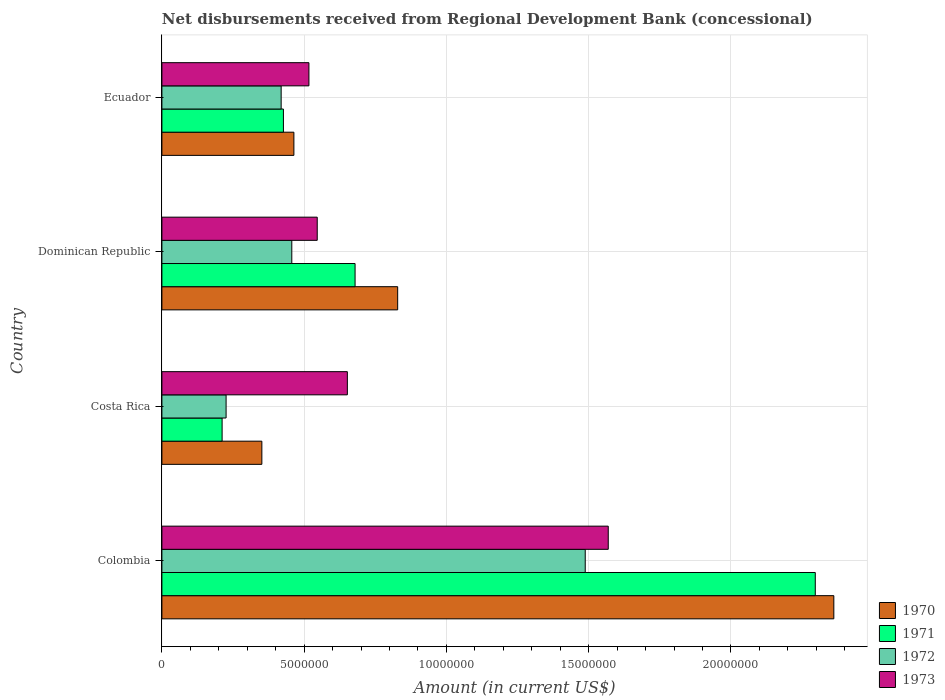How many groups of bars are there?
Ensure brevity in your answer.  4. Are the number of bars on each tick of the Y-axis equal?
Provide a succinct answer. Yes. How many bars are there on the 2nd tick from the bottom?
Give a very brief answer. 4. What is the label of the 2nd group of bars from the top?
Your answer should be very brief. Dominican Republic. In how many cases, is the number of bars for a given country not equal to the number of legend labels?
Make the answer very short. 0. What is the amount of disbursements received from Regional Development Bank in 1970 in Colombia?
Your answer should be compact. 2.36e+07. Across all countries, what is the maximum amount of disbursements received from Regional Development Bank in 1973?
Offer a terse response. 1.57e+07. Across all countries, what is the minimum amount of disbursements received from Regional Development Bank in 1972?
Your answer should be compact. 2.26e+06. In which country was the amount of disbursements received from Regional Development Bank in 1970 maximum?
Make the answer very short. Colombia. In which country was the amount of disbursements received from Regional Development Bank in 1973 minimum?
Provide a succinct answer. Ecuador. What is the total amount of disbursements received from Regional Development Bank in 1972 in the graph?
Provide a short and direct response. 2.59e+07. What is the difference between the amount of disbursements received from Regional Development Bank in 1972 in Colombia and that in Ecuador?
Your answer should be very brief. 1.07e+07. What is the difference between the amount of disbursements received from Regional Development Bank in 1972 in Dominican Republic and the amount of disbursements received from Regional Development Bank in 1970 in Costa Rica?
Your answer should be compact. 1.05e+06. What is the average amount of disbursements received from Regional Development Bank in 1971 per country?
Give a very brief answer. 9.03e+06. In how many countries, is the amount of disbursements received from Regional Development Bank in 1970 greater than 1000000 US$?
Make the answer very short. 4. What is the ratio of the amount of disbursements received from Regional Development Bank in 1972 in Costa Rica to that in Ecuador?
Make the answer very short. 0.54. What is the difference between the highest and the second highest amount of disbursements received from Regional Development Bank in 1973?
Make the answer very short. 9.17e+06. What is the difference between the highest and the lowest amount of disbursements received from Regional Development Bank in 1971?
Provide a succinct answer. 2.08e+07. In how many countries, is the amount of disbursements received from Regional Development Bank in 1970 greater than the average amount of disbursements received from Regional Development Bank in 1970 taken over all countries?
Provide a succinct answer. 1. Is the sum of the amount of disbursements received from Regional Development Bank in 1972 in Costa Rica and Dominican Republic greater than the maximum amount of disbursements received from Regional Development Bank in 1970 across all countries?
Your response must be concise. No. What does the 4th bar from the top in Colombia represents?
Ensure brevity in your answer.  1970. What does the 3rd bar from the bottom in Ecuador represents?
Keep it short and to the point. 1972. Is it the case that in every country, the sum of the amount of disbursements received from Regional Development Bank in 1970 and amount of disbursements received from Regional Development Bank in 1973 is greater than the amount of disbursements received from Regional Development Bank in 1972?
Provide a short and direct response. Yes. How many bars are there?
Give a very brief answer. 16. How many countries are there in the graph?
Your answer should be compact. 4. Are the values on the major ticks of X-axis written in scientific E-notation?
Your answer should be very brief. No. How are the legend labels stacked?
Provide a short and direct response. Vertical. What is the title of the graph?
Give a very brief answer. Net disbursements received from Regional Development Bank (concessional). What is the label or title of the Y-axis?
Your response must be concise. Country. What is the Amount (in current US$) in 1970 in Colombia?
Ensure brevity in your answer.  2.36e+07. What is the Amount (in current US$) in 1971 in Colombia?
Provide a short and direct response. 2.30e+07. What is the Amount (in current US$) of 1972 in Colombia?
Your answer should be very brief. 1.49e+07. What is the Amount (in current US$) in 1973 in Colombia?
Ensure brevity in your answer.  1.57e+07. What is the Amount (in current US$) of 1970 in Costa Rica?
Make the answer very short. 3.51e+06. What is the Amount (in current US$) of 1971 in Costa Rica?
Give a very brief answer. 2.12e+06. What is the Amount (in current US$) in 1972 in Costa Rica?
Your answer should be compact. 2.26e+06. What is the Amount (in current US$) in 1973 in Costa Rica?
Your answer should be compact. 6.52e+06. What is the Amount (in current US$) in 1970 in Dominican Republic?
Ensure brevity in your answer.  8.29e+06. What is the Amount (in current US$) in 1971 in Dominican Republic?
Make the answer very short. 6.79e+06. What is the Amount (in current US$) of 1972 in Dominican Republic?
Ensure brevity in your answer.  4.56e+06. What is the Amount (in current US$) in 1973 in Dominican Republic?
Provide a short and direct response. 5.46e+06. What is the Amount (in current US$) of 1970 in Ecuador?
Make the answer very short. 4.64e+06. What is the Amount (in current US$) of 1971 in Ecuador?
Your answer should be very brief. 4.27e+06. What is the Amount (in current US$) of 1972 in Ecuador?
Give a very brief answer. 4.19e+06. What is the Amount (in current US$) of 1973 in Ecuador?
Keep it short and to the point. 5.17e+06. Across all countries, what is the maximum Amount (in current US$) of 1970?
Keep it short and to the point. 2.36e+07. Across all countries, what is the maximum Amount (in current US$) in 1971?
Keep it short and to the point. 2.30e+07. Across all countries, what is the maximum Amount (in current US$) in 1972?
Ensure brevity in your answer.  1.49e+07. Across all countries, what is the maximum Amount (in current US$) of 1973?
Make the answer very short. 1.57e+07. Across all countries, what is the minimum Amount (in current US$) of 1970?
Keep it short and to the point. 3.51e+06. Across all countries, what is the minimum Amount (in current US$) of 1971?
Provide a succinct answer. 2.12e+06. Across all countries, what is the minimum Amount (in current US$) in 1972?
Provide a succinct answer. 2.26e+06. Across all countries, what is the minimum Amount (in current US$) in 1973?
Your answer should be very brief. 5.17e+06. What is the total Amount (in current US$) in 1970 in the graph?
Keep it short and to the point. 4.01e+07. What is the total Amount (in current US$) in 1971 in the graph?
Your answer should be very brief. 3.61e+07. What is the total Amount (in current US$) in 1972 in the graph?
Give a very brief answer. 2.59e+07. What is the total Amount (in current US$) in 1973 in the graph?
Give a very brief answer. 3.28e+07. What is the difference between the Amount (in current US$) in 1970 in Colombia and that in Costa Rica?
Offer a very short reply. 2.01e+07. What is the difference between the Amount (in current US$) of 1971 in Colombia and that in Costa Rica?
Keep it short and to the point. 2.08e+07. What is the difference between the Amount (in current US$) in 1972 in Colombia and that in Costa Rica?
Make the answer very short. 1.26e+07. What is the difference between the Amount (in current US$) in 1973 in Colombia and that in Costa Rica?
Give a very brief answer. 9.17e+06. What is the difference between the Amount (in current US$) in 1970 in Colombia and that in Dominican Republic?
Your answer should be compact. 1.53e+07. What is the difference between the Amount (in current US$) of 1971 in Colombia and that in Dominican Republic?
Offer a very short reply. 1.62e+07. What is the difference between the Amount (in current US$) in 1972 in Colombia and that in Dominican Republic?
Make the answer very short. 1.03e+07. What is the difference between the Amount (in current US$) in 1973 in Colombia and that in Dominican Republic?
Your answer should be very brief. 1.02e+07. What is the difference between the Amount (in current US$) in 1970 in Colombia and that in Ecuador?
Your answer should be compact. 1.90e+07. What is the difference between the Amount (in current US$) in 1971 in Colombia and that in Ecuador?
Ensure brevity in your answer.  1.87e+07. What is the difference between the Amount (in current US$) of 1972 in Colombia and that in Ecuador?
Offer a terse response. 1.07e+07. What is the difference between the Amount (in current US$) of 1973 in Colombia and that in Ecuador?
Provide a short and direct response. 1.05e+07. What is the difference between the Amount (in current US$) in 1970 in Costa Rica and that in Dominican Republic?
Your answer should be compact. -4.77e+06. What is the difference between the Amount (in current US$) of 1971 in Costa Rica and that in Dominican Republic?
Your response must be concise. -4.67e+06. What is the difference between the Amount (in current US$) of 1972 in Costa Rica and that in Dominican Republic?
Provide a short and direct response. -2.31e+06. What is the difference between the Amount (in current US$) of 1973 in Costa Rica and that in Dominican Republic?
Offer a very short reply. 1.06e+06. What is the difference between the Amount (in current US$) in 1970 in Costa Rica and that in Ecuador?
Your answer should be very brief. -1.13e+06. What is the difference between the Amount (in current US$) in 1971 in Costa Rica and that in Ecuador?
Offer a very short reply. -2.16e+06. What is the difference between the Amount (in current US$) of 1972 in Costa Rica and that in Ecuador?
Your response must be concise. -1.94e+06. What is the difference between the Amount (in current US$) in 1973 in Costa Rica and that in Ecuador?
Keep it short and to the point. 1.35e+06. What is the difference between the Amount (in current US$) of 1970 in Dominican Republic and that in Ecuador?
Give a very brief answer. 3.65e+06. What is the difference between the Amount (in current US$) of 1971 in Dominican Republic and that in Ecuador?
Provide a short and direct response. 2.52e+06. What is the difference between the Amount (in current US$) in 1972 in Dominican Republic and that in Ecuador?
Your answer should be very brief. 3.74e+05. What is the difference between the Amount (in current US$) of 1973 in Dominican Republic and that in Ecuador?
Ensure brevity in your answer.  2.92e+05. What is the difference between the Amount (in current US$) in 1970 in Colombia and the Amount (in current US$) in 1971 in Costa Rica?
Your answer should be compact. 2.15e+07. What is the difference between the Amount (in current US$) in 1970 in Colombia and the Amount (in current US$) in 1972 in Costa Rica?
Offer a terse response. 2.14e+07. What is the difference between the Amount (in current US$) in 1970 in Colombia and the Amount (in current US$) in 1973 in Costa Rica?
Provide a short and direct response. 1.71e+07. What is the difference between the Amount (in current US$) in 1971 in Colombia and the Amount (in current US$) in 1972 in Costa Rica?
Offer a very short reply. 2.07e+07. What is the difference between the Amount (in current US$) in 1971 in Colombia and the Amount (in current US$) in 1973 in Costa Rica?
Provide a succinct answer. 1.64e+07. What is the difference between the Amount (in current US$) in 1972 in Colombia and the Amount (in current US$) in 1973 in Costa Rica?
Your answer should be very brief. 8.36e+06. What is the difference between the Amount (in current US$) of 1970 in Colombia and the Amount (in current US$) of 1971 in Dominican Republic?
Give a very brief answer. 1.68e+07. What is the difference between the Amount (in current US$) in 1970 in Colombia and the Amount (in current US$) in 1972 in Dominican Republic?
Provide a short and direct response. 1.90e+07. What is the difference between the Amount (in current US$) of 1970 in Colombia and the Amount (in current US$) of 1973 in Dominican Republic?
Make the answer very short. 1.82e+07. What is the difference between the Amount (in current US$) of 1971 in Colombia and the Amount (in current US$) of 1972 in Dominican Republic?
Provide a succinct answer. 1.84e+07. What is the difference between the Amount (in current US$) of 1971 in Colombia and the Amount (in current US$) of 1973 in Dominican Republic?
Offer a terse response. 1.75e+07. What is the difference between the Amount (in current US$) of 1972 in Colombia and the Amount (in current US$) of 1973 in Dominican Republic?
Offer a very short reply. 9.42e+06. What is the difference between the Amount (in current US$) of 1970 in Colombia and the Amount (in current US$) of 1971 in Ecuador?
Give a very brief answer. 1.93e+07. What is the difference between the Amount (in current US$) in 1970 in Colombia and the Amount (in current US$) in 1972 in Ecuador?
Your answer should be very brief. 1.94e+07. What is the difference between the Amount (in current US$) in 1970 in Colombia and the Amount (in current US$) in 1973 in Ecuador?
Your response must be concise. 1.84e+07. What is the difference between the Amount (in current US$) of 1971 in Colombia and the Amount (in current US$) of 1972 in Ecuador?
Keep it short and to the point. 1.88e+07. What is the difference between the Amount (in current US$) in 1971 in Colombia and the Amount (in current US$) in 1973 in Ecuador?
Offer a terse response. 1.78e+07. What is the difference between the Amount (in current US$) in 1972 in Colombia and the Amount (in current US$) in 1973 in Ecuador?
Your answer should be compact. 9.71e+06. What is the difference between the Amount (in current US$) in 1970 in Costa Rica and the Amount (in current US$) in 1971 in Dominican Republic?
Provide a short and direct response. -3.28e+06. What is the difference between the Amount (in current US$) of 1970 in Costa Rica and the Amount (in current US$) of 1972 in Dominican Republic?
Your response must be concise. -1.05e+06. What is the difference between the Amount (in current US$) in 1970 in Costa Rica and the Amount (in current US$) in 1973 in Dominican Republic?
Provide a short and direct response. -1.95e+06. What is the difference between the Amount (in current US$) of 1971 in Costa Rica and the Amount (in current US$) of 1972 in Dominican Republic?
Ensure brevity in your answer.  -2.45e+06. What is the difference between the Amount (in current US$) in 1971 in Costa Rica and the Amount (in current US$) in 1973 in Dominican Republic?
Provide a short and direct response. -3.34e+06. What is the difference between the Amount (in current US$) in 1972 in Costa Rica and the Amount (in current US$) in 1973 in Dominican Republic?
Offer a very short reply. -3.20e+06. What is the difference between the Amount (in current US$) of 1970 in Costa Rica and the Amount (in current US$) of 1971 in Ecuador?
Give a very brief answer. -7.58e+05. What is the difference between the Amount (in current US$) of 1970 in Costa Rica and the Amount (in current US$) of 1972 in Ecuador?
Your answer should be very brief. -6.78e+05. What is the difference between the Amount (in current US$) of 1970 in Costa Rica and the Amount (in current US$) of 1973 in Ecuador?
Provide a succinct answer. -1.65e+06. What is the difference between the Amount (in current US$) in 1971 in Costa Rica and the Amount (in current US$) in 1972 in Ecuador?
Provide a short and direct response. -2.08e+06. What is the difference between the Amount (in current US$) in 1971 in Costa Rica and the Amount (in current US$) in 1973 in Ecuador?
Keep it short and to the point. -3.05e+06. What is the difference between the Amount (in current US$) in 1972 in Costa Rica and the Amount (in current US$) in 1973 in Ecuador?
Your answer should be compact. -2.91e+06. What is the difference between the Amount (in current US$) of 1970 in Dominican Republic and the Amount (in current US$) of 1971 in Ecuador?
Keep it short and to the point. 4.02e+06. What is the difference between the Amount (in current US$) in 1970 in Dominican Republic and the Amount (in current US$) in 1972 in Ecuador?
Provide a succinct answer. 4.10e+06. What is the difference between the Amount (in current US$) of 1970 in Dominican Republic and the Amount (in current US$) of 1973 in Ecuador?
Offer a very short reply. 3.12e+06. What is the difference between the Amount (in current US$) in 1971 in Dominican Republic and the Amount (in current US$) in 1972 in Ecuador?
Offer a very short reply. 2.60e+06. What is the difference between the Amount (in current US$) in 1971 in Dominican Republic and the Amount (in current US$) in 1973 in Ecuador?
Provide a short and direct response. 1.62e+06. What is the difference between the Amount (in current US$) of 1972 in Dominican Republic and the Amount (in current US$) of 1973 in Ecuador?
Give a very brief answer. -6.02e+05. What is the average Amount (in current US$) in 1970 per country?
Offer a terse response. 1.00e+07. What is the average Amount (in current US$) of 1971 per country?
Your answer should be very brief. 9.03e+06. What is the average Amount (in current US$) in 1972 per country?
Your answer should be compact. 6.47e+06. What is the average Amount (in current US$) of 1973 per country?
Ensure brevity in your answer.  8.21e+06. What is the difference between the Amount (in current US$) in 1970 and Amount (in current US$) in 1971 in Colombia?
Make the answer very short. 6.52e+05. What is the difference between the Amount (in current US$) of 1970 and Amount (in current US$) of 1972 in Colombia?
Provide a short and direct response. 8.74e+06. What is the difference between the Amount (in current US$) of 1970 and Amount (in current US$) of 1973 in Colombia?
Offer a very short reply. 7.93e+06. What is the difference between the Amount (in current US$) of 1971 and Amount (in current US$) of 1972 in Colombia?
Offer a terse response. 8.08e+06. What is the difference between the Amount (in current US$) of 1971 and Amount (in current US$) of 1973 in Colombia?
Your response must be concise. 7.28e+06. What is the difference between the Amount (in current US$) in 1972 and Amount (in current US$) in 1973 in Colombia?
Offer a very short reply. -8.09e+05. What is the difference between the Amount (in current US$) in 1970 and Amount (in current US$) in 1971 in Costa Rica?
Offer a very short reply. 1.40e+06. What is the difference between the Amount (in current US$) of 1970 and Amount (in current US$) of 1972 in Costa Rica?
Make the answer very short. 1.26e+06. What is the difference between the Amount (in current US$) of 1970 and Amount (in current US$) of 1973 in Costa Rica?
Your answer should be very brief. -3.00e+06. What is the difference between the Amount (in current US$) in 1971 and Amount (in current US$) in 1973 in Costa Rica?
Your answer should be very brief. -4.40e+06. What is the difference between the Amount (in current US$) in 1972 and Amount (in current US$) in 1973 in Costa Rica?
Give a very brief answer. -4.26e+06. What is the difference between the Amount (in current US$) in 1970 and Amount (in current US$) in 1971 in Dominican Republic?
Your answer should be compact. 1.50e+06. What is the difference between the Amount (in current US$) of 1970 and Amount (in current US$) of 1972 in Dominican Republic?
Your response must be concise. 3.72e+06. What is the difference between the Amount (in current US$) of 1970 and Amount (in current US$) of 1973 in Dominican Republic?
Provide a succinct answer. 2.83e+06. What is the difference between the Amount (in current US$) of 1971 and Amount (in current US$) of 1972 in Dominican Republic?
Offer a very short reply. 2.22e+06. What is the difference between the Amount (in current US$) in 1971 and Amount (in current US$) in 1973 in Dominican Republic?
Provide a short and direct response. 1.33e+06. What is the difference between the Amount (in current US$) of 1972 and Amount (in current US$) of 1973 in Dominican Republic?
Your answer should be compact. -8.94e+05. What is the difference between the Amount (in current US$) of 1970 and Amount (in current US$) of 1971 in Ecuador?
Your answer should be very brief. 3.68e+05. What is the difference between the Amount (in current US$) of 1970 and Amount (in current US$) of 1972 in Ecuador?
Your answer should be very brief. 4.48e+05. What is the difference between the Amount (in current US$) of 1970 and Amount (in current US$) of 1973 in Ecuador?
Your answer should be very brief. -5.28e+05. What is the difference between the Amount (in current US$) in 1971 and Amount (in current US$) in 1973 in Ecuador?
Make the answer very short. -8.96e+05. What is the difference between the Amount (in current US$) in 1972 and Amount (in current US$) in 1973 in Ecuador?
Provide a short and direct response. -9.76e+05. What is the ratio of the Amount (in current US$) of 1970 in Colombia to that in Costa Rica?
Make the answer very short. 6.72. What is the ratio of the Amount (in current US$) of 1971 in Colombia to that in Costa Rica?
Make the answer very short. 10.85. What is the ratio of the Amount (in current US$) in 1972 in Colombia to that in Costa Rica?
Ensure brevity in your answer.  6.59. What is the ratio of the Amount (in current US$) in 1973 in Colombia to that in Costa Rica?
Offer a terse response. 2.41. What is the ratio of the Amount (in current US$) of 1970 in Colombia to that in Dominican Republic?
Give a very brief answer. 2.85. What is the ratio of the Amount (in current US$) in 1971 in Colombia to that in Dominican Republic?
Your answer should be compact. 3.38. What is the ratio of the Amount (in current US$) of 1972 in Colombia to that in Dominican Republic?
Provide a short and direct response. 3.26. What is the ratio of the Amount (in current US$) of 1973 in Colombia to that in Dominican Republic?
Offer a very short reply. 2.87. What is the ratio of the Amount (in current US$) of 1970 in Colombia to that in Ecuador?
Make the answer very short. 5.09. What is the ratio of the Amount (in current US$) of 1971 in Colombia to that in Ecuador?
Provide a succinct answer. 5.38. What is the ratio of the Amount (in current US$) in 1972 in Colombia to that in Ecuador?
Ensure brevity in your answer.  3.55. What is the ratio of the Amount (in current US$) in 1973 in Colombia to that in Ecuador?
Ensure brevity in your answer.  3.04. What is the ratio of the Amount (in current US$) in 1970 in Costa Rica to that in Dominican Republic?
Give a very brief answer. 0.42. What is the ratio of the Amount (in current US$) of 1971 in Costa Rica to that in Dominican Republic?
Provide a succinct answer. 0.31. What is the ratio of the Amount (in current US$) of 1972 in Costa Rica to that in Dominican Republic?
Offer a very short reply. 0.49. What is the ratio of the Amount (in current US$) in 1973 in Costa Rica to that in Dominican Republic?
Your response must be concise. 1.19. What is the ratio of the Amount (in current US$) in 1970 in Costa Rica to that in Ecuador?
Provide a succinct answer. 0.76. What is the ratio of the Amount (in current US$) of 1971 in Costa Rica to that in Ecuador?
Offer a very short reply. 0.5. What is the ratio of the Amount (in current US$) of 1972 in Costa Rica to that in Ecuador?
Offer a terse response. 0.54. What is the ratio of the Amount (in current US$) in 1973 in Costa Rica to that in Ecuador?
Your response must be concise. 1.26. What is the ratio of the Amount (in current US$) in 1970 in Dominican Republic to that in Ecuador?
Your answer should be compact. 1.79. What is the ratio of the Amount (in current US$) of 1971 in Dominican Republic to that in Ecuador?
Provide a short and direct response. 1.59. What is the ratio of the Amount (in current US$) of 1972 in Dominican Republic to that in Ecuador?
Provide a succinct answer. 1.09. What is the ratio of the Amount (in current US$) in 1973 in Dominican Republic to that in Ecuador?
Your response must be concise. 1.06. What is the difference between the highest and the second highest Amount (in current US$) of 1970?
Provide a short and direct response. 1.53e+07. What is the difference between the highest and the second highest Amount (in current US$) of 1971?
Ensure brevity in your answer.  1.62e+07. What is the difference between the highest and the second highest Amount (in current US$) in 1972?
Keep it short and to the point. 1.03e+07. What is the difference between the highest and the second highest Amount (in current US$) of 1973?
Ensure brevity in your answer.  9.17e+06. What is the difference between the highest and the lowest Amount (in current US$) in 1970?
Your response must be concise. 2.01e+07. What is the difference between the highest and the lowest Amount (in current US$) in 1971?
Your response must be concise. 2.08e+07. What is the difference between the highest and the lowest Amount (in current US$) of 1972?
Keep it short and to the point. 1.26e+07. What is the difference between the highest and the lowest Amount (in current US$) in 1973?
Offer a very short reply. 1.05e+07. 